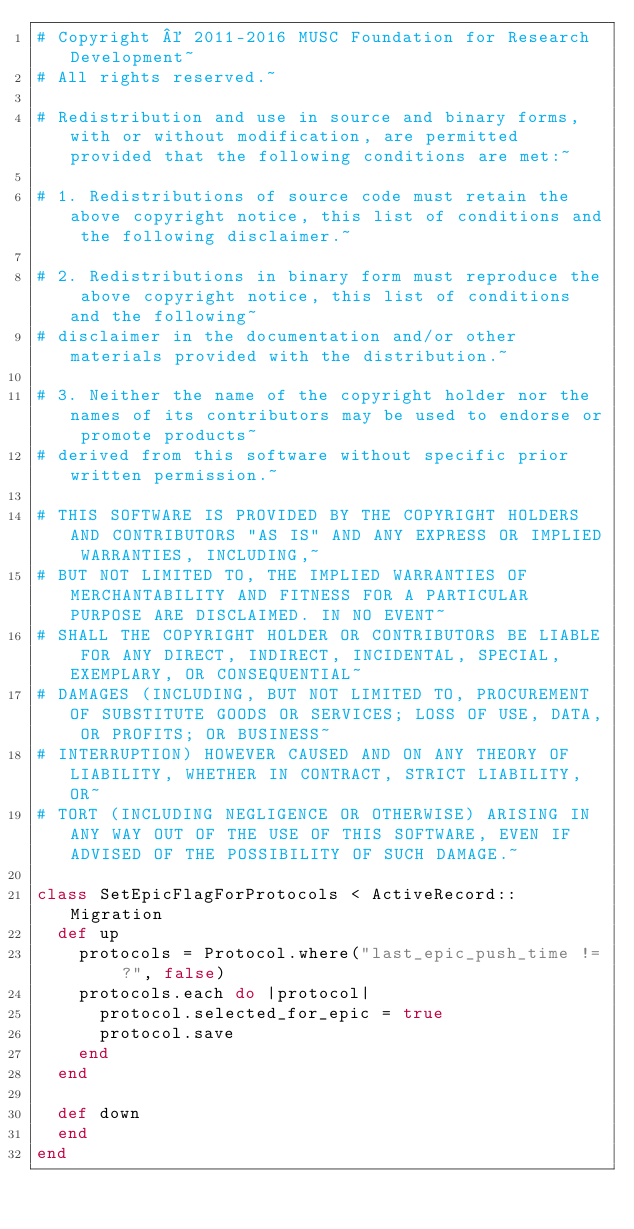Convert code to text. <code><loc_0><loc_0><loc_500><loc_500><_Ruby_># Copyright © 2011-2016 MUSC Foundation for Research Development~
# All rights reserved.~

# Redistribution and use in source and binary forms, with or without modification, are permitted provided that the following conditions are met:~

# 1. Redistributions of source code must retain the above copyright notice, this list of conditions and the following disclaimer.~

# 2. Redistributions in binary form must reproduce the above copyright notice, this list of conditions and the following~
# disclaimer in the documentation and/or other materials provided with the distribution.~

# 3. Neither the name of the copyright holder nor the names of its contributors may be used to endorse or promote products~
# derived from this software without specific prior written permission.~

# THIS SOFTWARE IS PROVIDED BY THE COPYRIGHT HOLDERS AND CONTRIBUTORS "AS IS" AND ANY EXPRESS OR IMPLIED WARRANTIES, INCLUDING,~
# BUT NOT LIMITED TO, THE IMPLIED WARRANTIES OF MERCHANTABILITY AND FITNESS FOR A PARTICULAR PURPOSE ARE DISCLAIMED. IN NO EVENT~
# SHALL THE COPYRIGHT HOLDER OR CONTRIBUTORS BE LIABLE FOR ANY DIRECT, INDIRECT, INCIDENTAL, SPECIAL, EXEMPLARY, OR CONSEQUENTIAL~
# DAMAGES (INCLUDING, BUT NOT LIMITED TO, PROCUREMENT OF SUBSTITUTE GOODS OR SERVICES; LOSS OF USE, DATA, OR PROFITS; OR BUSINESS~
# INTERRUPTION) HOWEVER CAUSED AND ON ANY THEORY OF LIABILITY, WHETHER IN CONTRACT, STRICT LIABILITY, OR~
# TORT (INCLUDING NEGLIGENCE OR OTHERWISE) ARISING IN ANY WAY OUT OF THE USE OF THIS SOFTWARE, EVEN IF ADVISED OF THE POSSIBILITY OF SUCH DAMAGE.~

class SetEpicFlagForProtocols < ActiveRecord::Migration
  def up
    protocols = Protocol.where("last_epic_push_time != ?", false)
    protocols.each do |protocol|
      protocol.selected_for_epic = true
      protocol.save
    end
  end

  def down
  end
end
</code> 